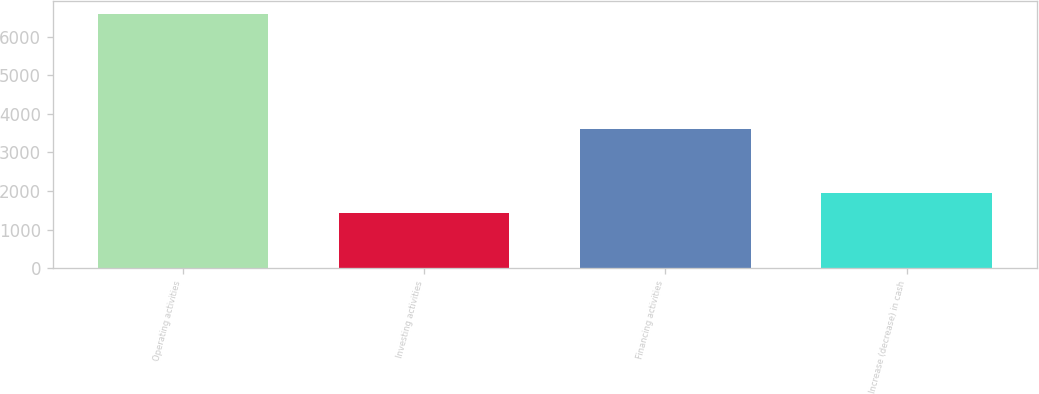Convert chart to OTSL. <chart><loc_0><loc_0><loc_500><loc_500><bar_chart><fcel>Operating activities<fcel>Investing activities<fcel>Financing activities<fcel>Increase (decrease) in cash<nl><fcel>6584<fcel>1435<fcel>3603<fcel>1949.9<nl></chart> 